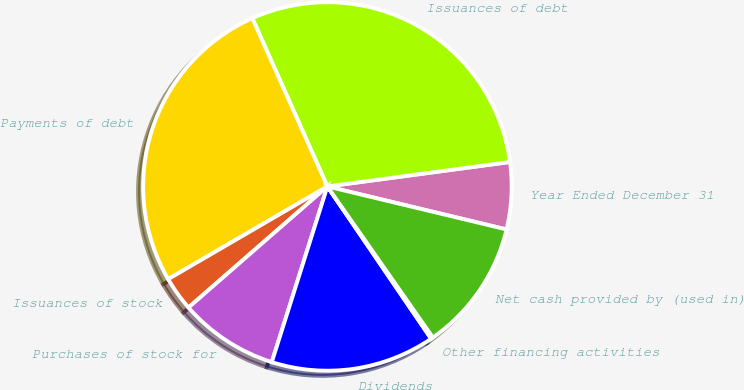Convert chart. <chart><loc_0><loc_0><loc_500><loc_500><pie_chart><fcel>Year Ended December 31<fcel>Issuances of debt<fcel>Payments of debt<fcel>Issuances of stock<fcel>Purchases of stock for<fcel>Dividends<fcel>Other financing activities<fcel>Net cash provided by (used in)<nl><fcel>5.87%<fcel>29.56%<fcel>26.71%<fcel>3.02%<fcel>8.71%<fcel>14.4%<fcel>0.18%<fcel>11.55%<nl></chart> 